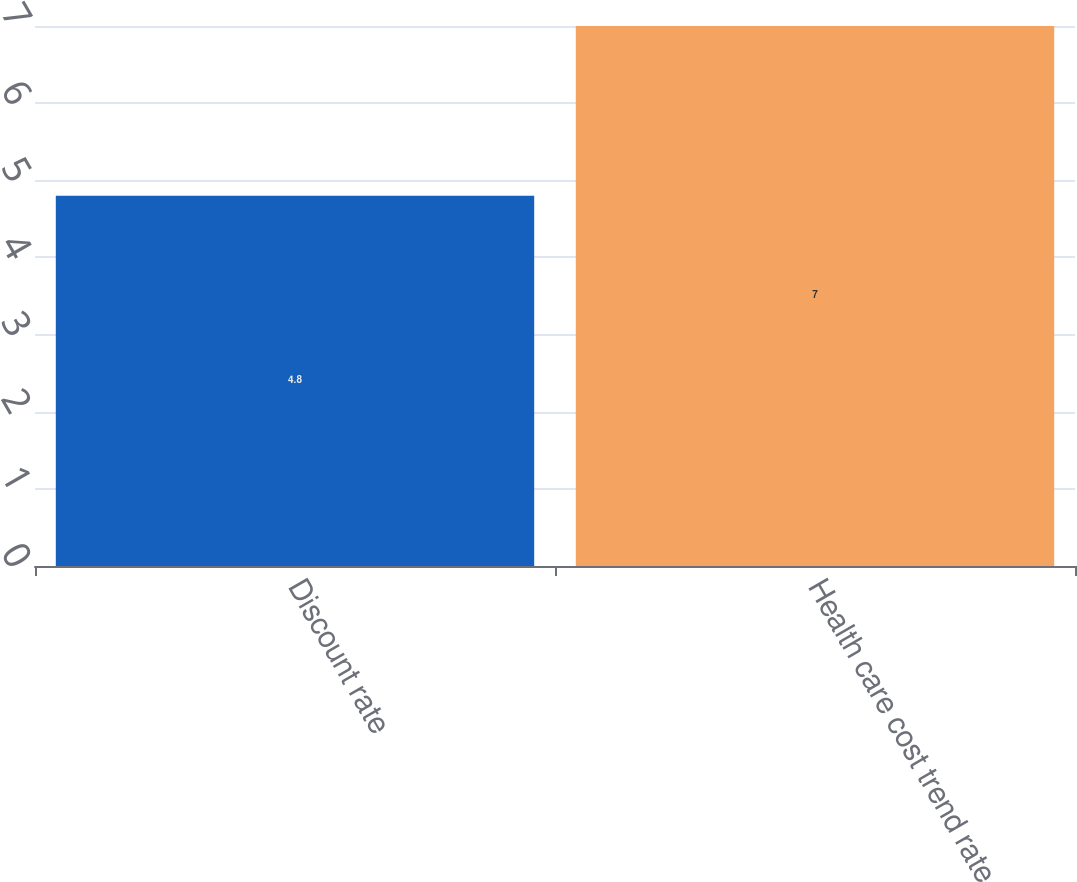<chart> <loc_0><loc_0><loc_500><loc_500><bar_chart><fcel>Discount rate<fcel>Health care cost trend rate<nl><fcel>4.8<fcel>7<nl></chart> 